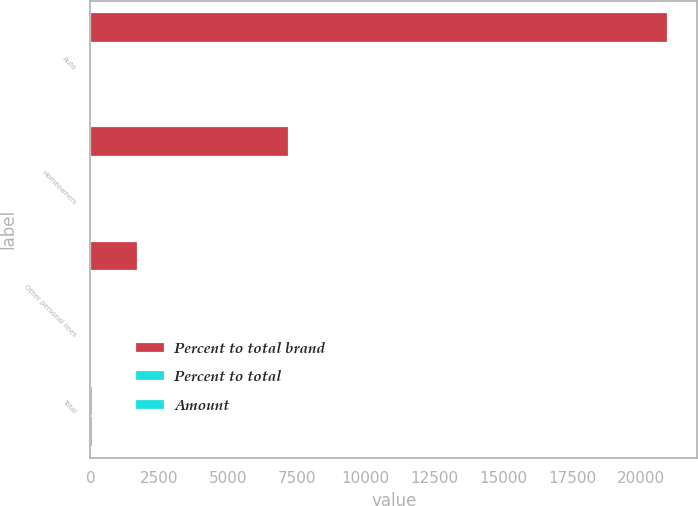Convert chart to OTSL. <chart><loc_0><loc_0><loc_500><loc_500><stacked_bar_chart><ecel><fcel>Auto<fcel>Homeowners<fcel>Other personal lines<fcel>Total<nl><fcel>Percent to total brand<fcel>20991<fcel>7199<fcel>1742<fcel>69.6<nl><fcel>Percent to total<fcel>68.6<fcel>23.5<fcel>5.7<fcel>100<nl><fcel>Amount<fcel>69.6<fcel>22.9<fcel>5.5<fcel>100<nl></chart> 